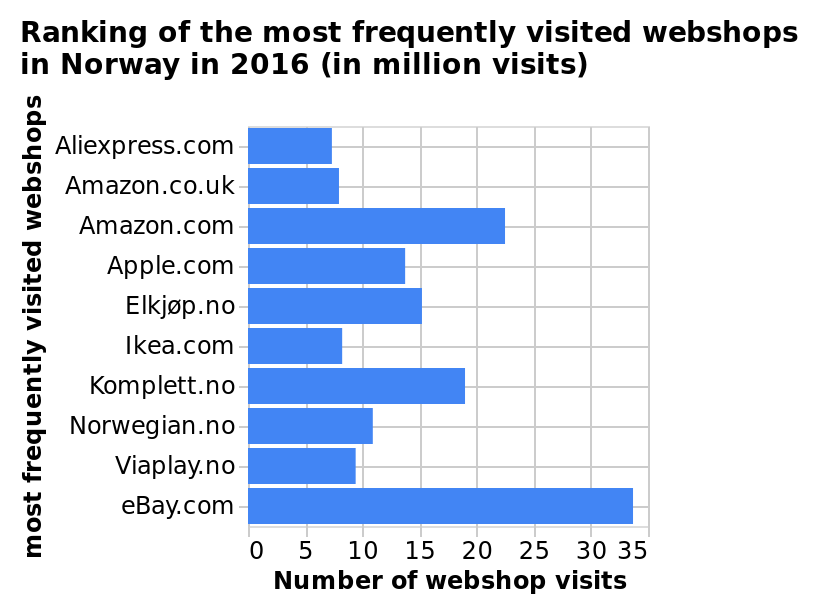<image>
Which year was EBay the most visited webshop in Norway? EBay was the most visited webshop in Norway in 2016. please summary the statistics and relations of the chart I can see in the bar chart that eBay and Amazon are the most popular web shops in norway, rather than the native norweigen sites such as ‘Elkjøp.no in the graph. 